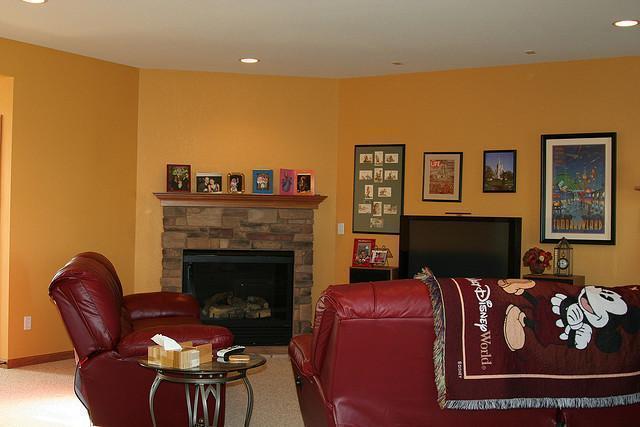What natural element might be found here?
Pick the right solution, then justify: 'Answer: answer
Rationale: rationale.'
Options: Earth, air, water, fire. Answer: fire.
Rationale: There is an alcove with a chimney attached that is meant for burning items to warm the room. 